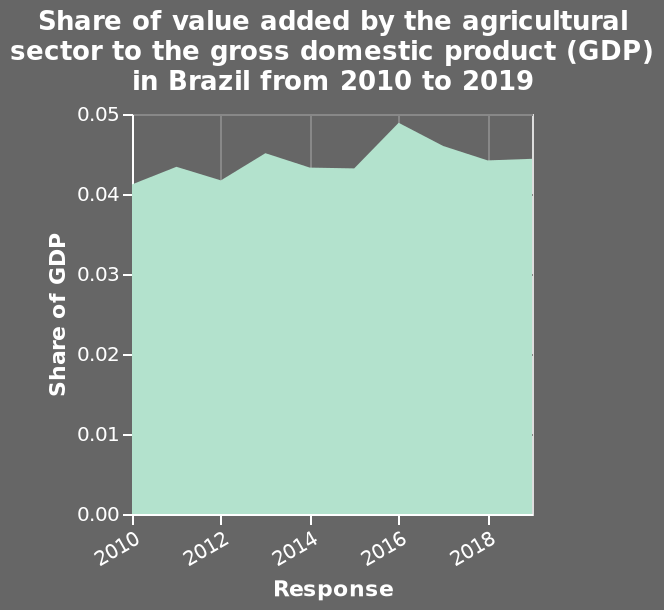<image>
What is the maximum share of GDP shown on the y-axis of the area plot? The maximum share of GDP shown on the y-axis of the area plot is 0.05. What is the range of the x-axis in the area plot?  The x-axis of the area plot ranges from 2010 to 2018. What was the share of value added by the agricultural sector to Brazil's GDP in 2016? The share of value added by the agricultural sector to Brazil's GDP was at its highest in 2016. What is the range of the y-axis in the area plot?  The y-axis of the area plot ranges from 0.00 to 0.05. 